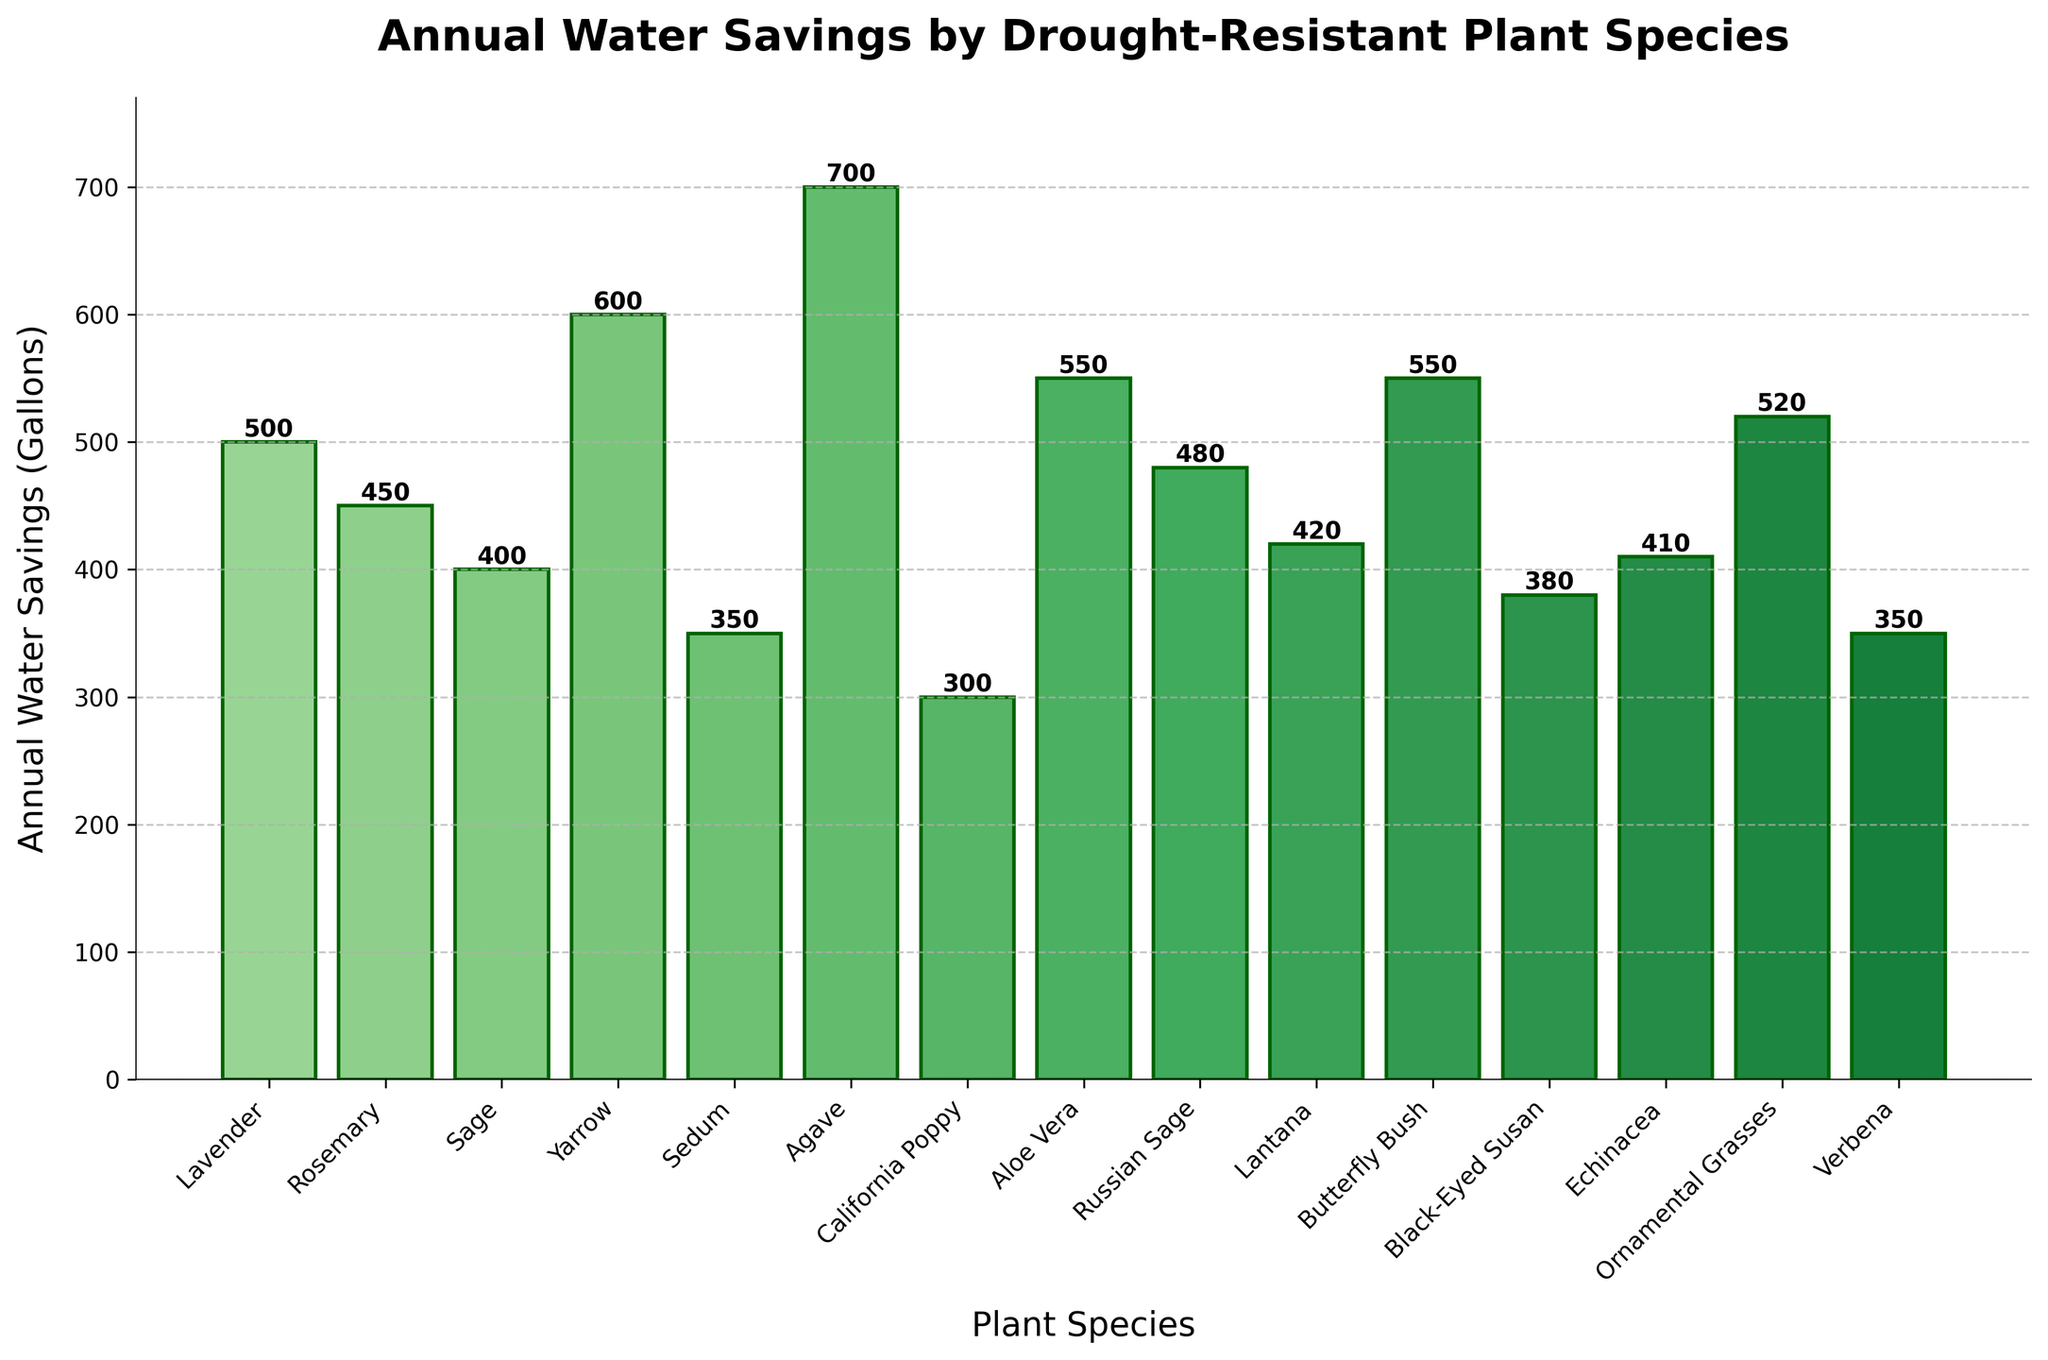What is the plant species with the highest annual water savings? The bar corresponding to Agave has the highest height, representing the highest annual water savings.
Answer: Agave Which plant species has the lowest annual water savings? The shortest bar corresponds to California Poppy, indicating the lowest annual water savings.
Answer: California Poppy How much more water does Agave save annually compared to Lavender? Agave saves 700 gallons, and Lavender saves 500 gallons; the difference is 700 - 500 = 200 gallons.
Answer: 200 gallons Are there any plant species that have the same annual water savings? Both Aloe Vera and Butterfly Bush have bars reaching 550 gallons, indicating they save the same amount of water annually.
Answer: Yes, Aloe Vera and Butterfly Bush What is the total annual water savings for Lavender and Rosemary combined? Lavender saves 500 gallons and Rosemary saves 450 gallons. The total is 500 + 450 = 950 gallons.
Answer: 950 gallons Which plant species saves more water annually, Lantana or Yarrow? Yarrow’s bar is taller than Lantana's, indicating Yarrow saves more water annually.
Answer: Yarrow What is the average annual water savings of California Poppy, Verbena, and Sedum? California Poppy saves 300 gallons, Verbena saves 350 gallons, and Sedum saves 350 gallons. The average is (300 + 350 + 350) / 3 = 333 gallons.
Answer: 333 gallons Which plant species are saving between 400 and 500 gallons annually? Russian Sage saves 480 gallons, Lantana saves 420 gallons, Sage saves 400 gallons, and Echinacea saves 410 gallons.
Answer: Russian Sage, Lantana, Sage, and Echinacea How does the water savings of Sage compare to Black-Eyed Susan? Sage saves 400 gallons, and Black-Eyed Susan saves 380 gallons; Sage saves 20 gallons more than Black-Eyed Susan.
Answer: Sage saves more By how much do the annual water savings of Ornamental Grasses exceed those of Lantana? Ornamental Grasses save 520 gallons, and Lantana saves 420 gallons; the difference is 520 - 420 = 100 gallons.
Answer: 100 gallons 